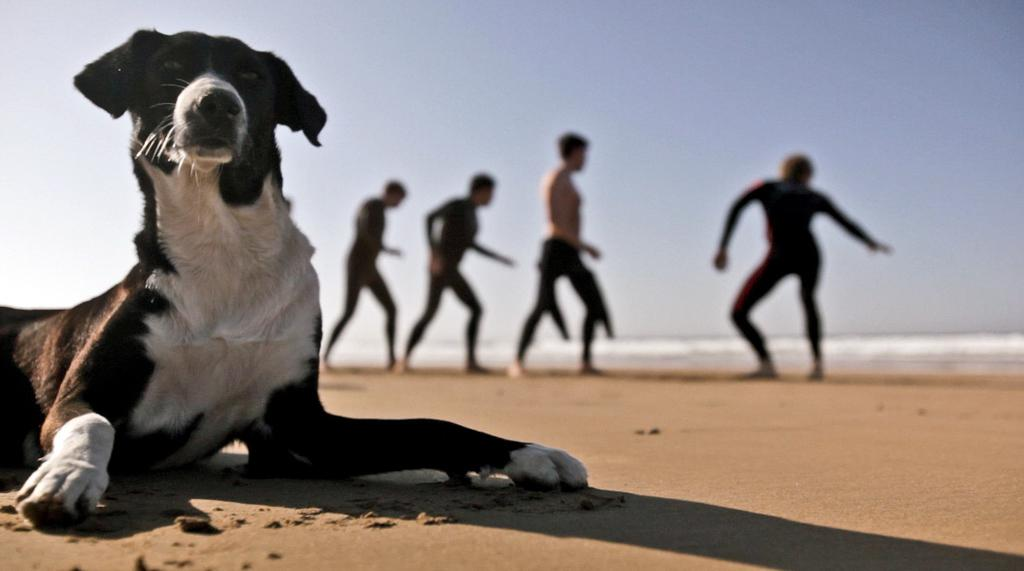What can be seen in the image? There are persons standing in the image, and there is a dog in the image. What is visible in the background of the image? The sky is visible in the image. What type of brush is being used by the persons in the image? There is no brush present in the image; the persons are simply standing with a dog. 